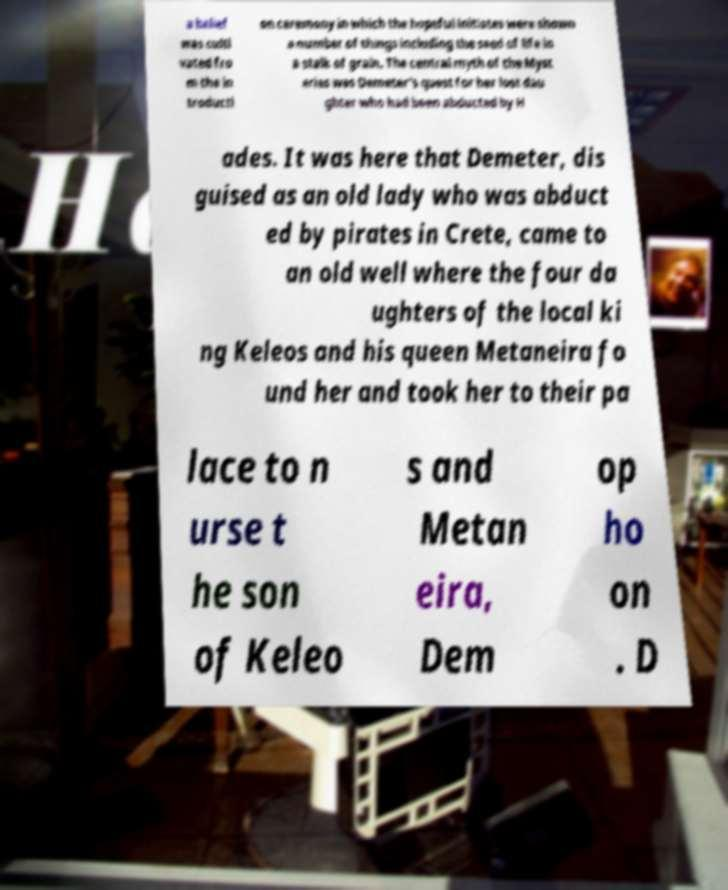Could you assist in decoding the text presented in this image and type it out clearly? a belief was culti vated fro m the in troducti on ceremony in which the hopeful initiates were shown a number of things including the seed of life in a stalk of grain. The central myth of the Myst eries was Demeter's quest for her lost dau ghter who had been abducted by H ades. It was here that Demeter, dis guised as an old lady who was abduct ed by pirates in Crete, came to an old well where the four da ughters of the local ki ng Keleos and his queen Metaneira fo und her and took her to their pa lace to n urse t he son of Keleo s and Metan eira, Dem op ho on . D 